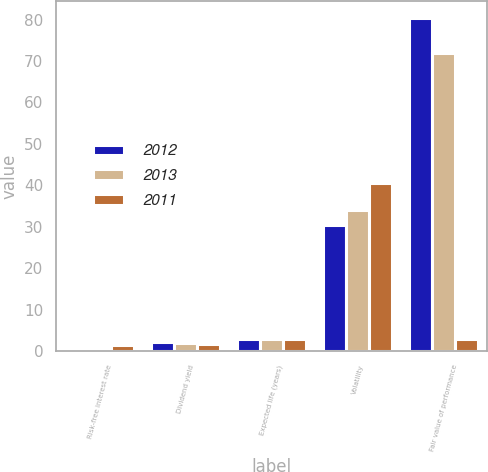<chart> <loc_0><loc_0><loc_500><loc_500><stacked_bar_chart><ecel><fcel>Risk-free interest rate<fcel>Dividend yield<fcel>Expected life (years)<fcel>Volatility<fcel>Fair value of performance<nl><fcel>2012<fcel>0.4<fcel>2.06<fcel>2.9<fcel>30.36<fcel>80.47<nl><fcel>2013<fcel>0.37<fcel>2.03<fcel>2.9<fcel>34.1<fcel>71.98<nl><fcel>2011<fcel>1.34<fcel>1.61<fcel>2.9<fcel>40.48<fcel>2.9<nl></chart> 